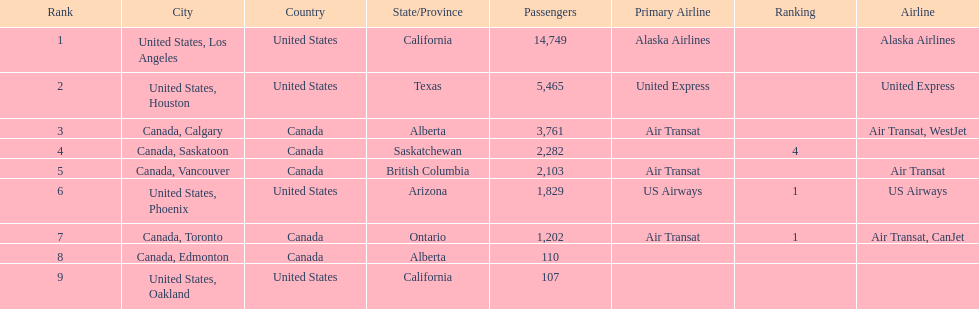Could you parse the entire table as a dict? {'header': ['Rank', 'City', 'Country', 'State/Province', 'Passengers', 'Primary Airline', 'Ranking', 'Airline'], 'rows': [['1', 'United States, Los Angeles', 'United States', 'California', '14,749', 'Alaska Airlines', '', 'Alaska Airlines'], ['2', 'United States, Houston', 'United States', 'Texas', '5,465', 'United Express', '', 'United Express'], ['3', 'Canada, Calgary', 'Canada', 'Alberta', '3,761', 'Air Transat', '', 'Air Transat, WestJet'], ['4', 'Canada, Saskatoon', 'Canada', 'Saskatchewan', '2,282', '', '4', ''], ['5', 'Canada, Vancouver', 'Canada', 'British Columbia', '2,103', 'Air Transat', '', 'Air Transat'], ['6', 'United States, Phoenix', 'United States', 'Arizona', '1,829', 'US Airways', '1', 'US Airways'], ['7', 'Canada, Toronto', 'Canada', 'Ontario', '1,202', 'Air Transat', '1', 'Air Transat, CanJet'], ['8', 'Canada, Edmonton', 'Canada', 'Alberta', '110', '', '', ''], ['9', 'United States, Oakland', 'United States', 'California', '107', '', '', '']]} Was los angeles or houston the busiest international route at manzanillo international airport in 2013? Los Angeles. 